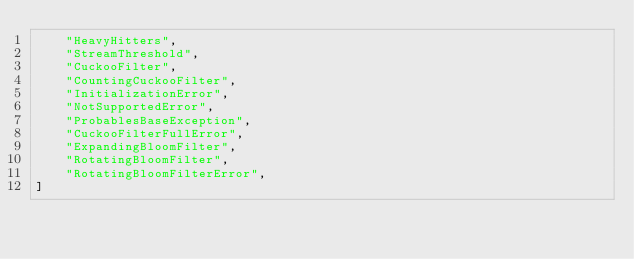<code> <loc_0><loc_0><loc_500><loc_500><_Python_>    "HeavyHitters",
    "StreamThreshold",
    "CuckooFilter",
    "CountingCuckooFilter",
    "InitializationError",
    "NotSupportedError",
    "ProbablesBaseException",
    "CuckooFilterFullError",
    "ExpandingBloomFilter",
    "RotatingBloomFilter",
    "RotatingBloomFilterError",
]
</code> 